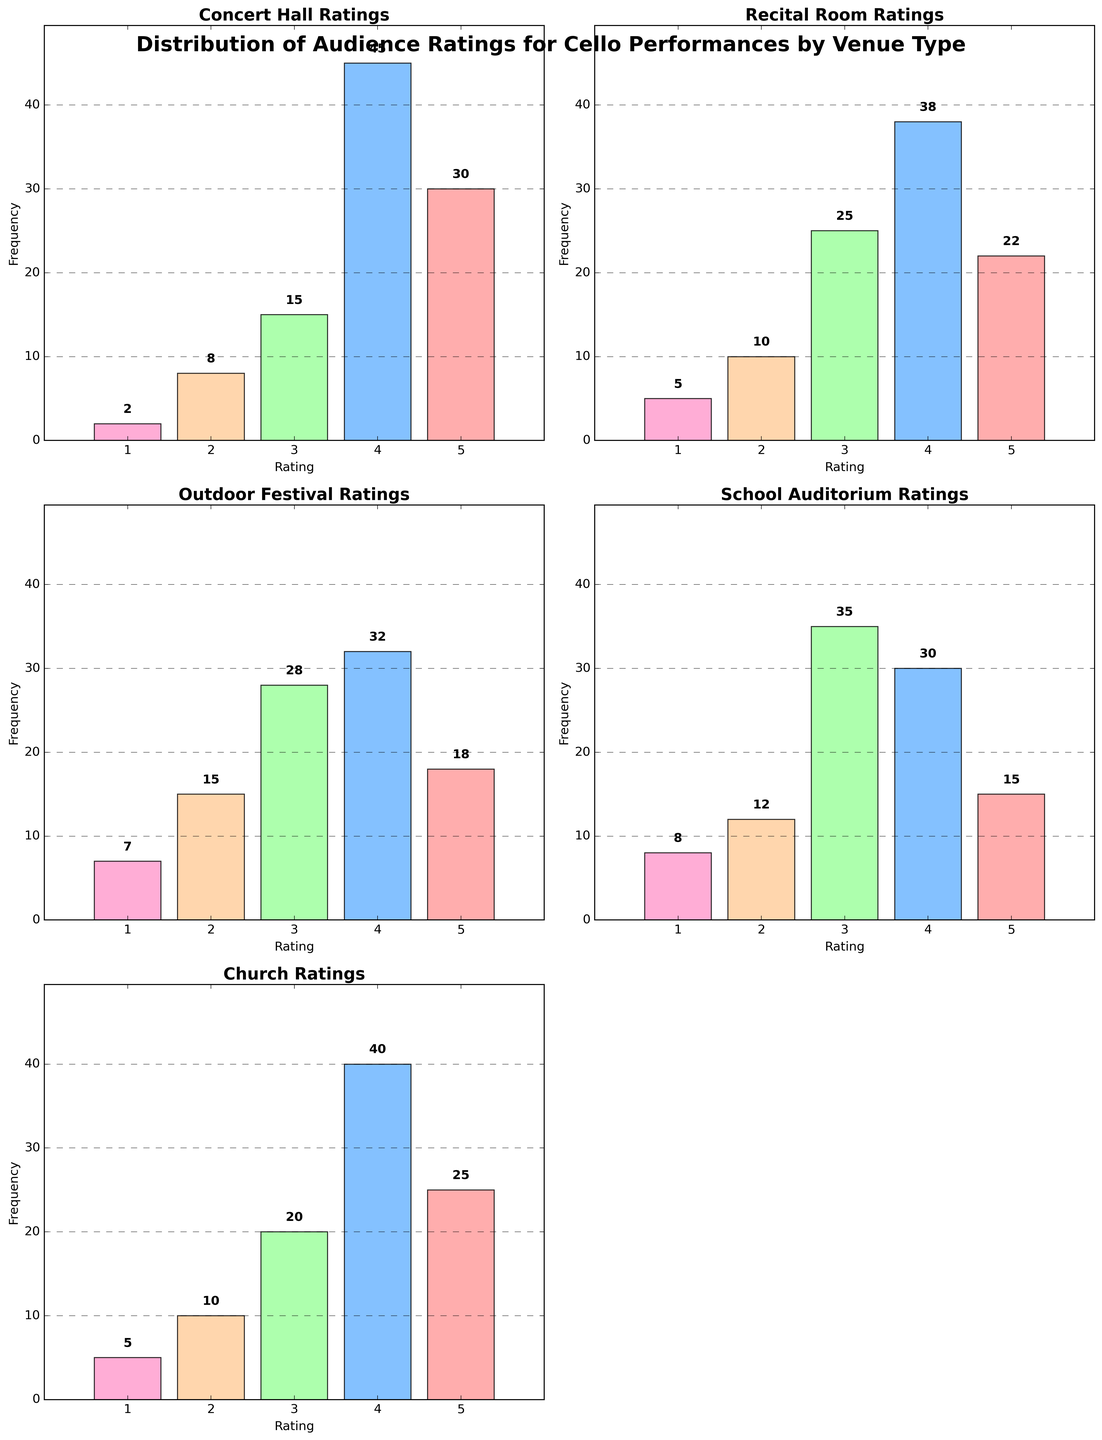What venue type has the highest number of 5-star ratings? Each subplot represents a different venue type and shows the frequency of each rating. By looking at the bar heights for the 5-star ratings across all subplots, we can see that the Concert Hall, with a frequency of 30, has the highest number of 5-star ratings.
Answer: Concert Hall Which rating is the most frequent in the Outdoor Festival venue? The frequency of each rating in the Outdoor Festival venue can be found from the heights of the bars. The 4-star rating has the highest bar with a frequency of 32, making it the most frequent.
Answer: 4-star How many 1-star ratings were given in total across all venue types? To find the total number of 1-star ratings, we need to sum the frequencies of the 1-star ratings from all subplots. The frequencies are: Concert Hall: 2, Recital Room: 5, Outdoor Festival: 7, School Auditorium: 8, Church: 5. The total is 2 + 5 + 7 + 8 + 5 = 27.
Answer: 27 Which venue type has the lowest frequency of 2-star ratings, and what is the value? By comparing the heights of the 2-star bars across all venue types, we notice the Concert Hall has the lowest 2-star rating frequency at 8.
Answer: Concert Hall, 8 What is the average frequency of 3-star ratings across all venues? We need to sum the frequencies of 3-star ratings across all venues and divide by the number of venue types. The frequencies are: Concert Hall: 15, Recital Room: 25, Outdoor Festival: 28, School Auditorium: 35, Church: 20. The total is 15 + 25 + 28 + 35 + 20 = 123. The average is 123 / 5 = 24.6.
Answer: 24.6 Which venue type has a more even distribution of ratings? To determine the venue with the most even distribution, we look for the venue where the bars are more similar in height. The Recital Room has bars that are more evenly distributed across ratings compared to other venues.
Answer: Recital Room Is there a venue type where the 4-star ratings are greater than the 5-star ratings? We look for venues where the frequency of 4-star ratings exceeds that of 5-star ratings: Concert Hall (45 > 30), Recital Room (38 > 22), Outdoor Festival (32 > 18), School Auditorium (30 > 15), Church (40 > 25). All venues meet this criterion.
Answer: Yes, all How many total ratings were given in the Church venue? Sum the frequencies of all ratings in the Church venue: 25 (5-star) + 40 (4-star) + 20 (3-star) + 10 (2-star) + 5 (1-star) = 100.
Answer: 100 Which rating is least frequent in the School Auditorium? By examining the heights of bars in the School Auditorium subplot, the 1-star rating is the least frequent with a frequency of 8.
Answer: 1-star What is the combined frequency of 5-star and 4-star ratings in Recital Room? We add the frequencies of 5-star and 4-star ratings in the Recital Room: 22 (5-star) + 38 (4-star) = 60.
Answer: 60 